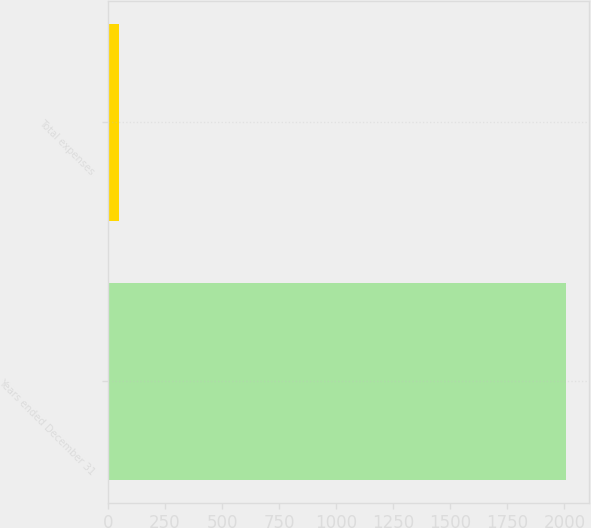Convert chart. <chart><loc_0><loc_0><loc_500><loc_500><bar_chart><fcel>Years ended December 31<fcel>Total expenses<nl><fcel>2009<fcel>49<nl></chart> 